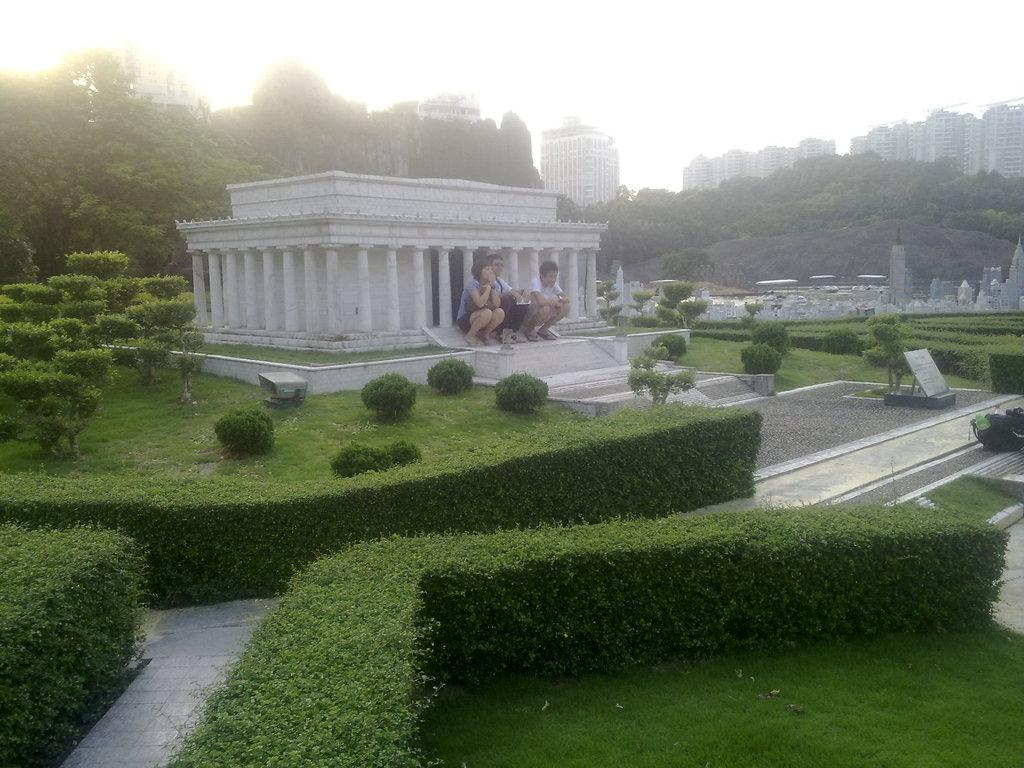What type of structures can be seen in the image? There are buildings in the image. What other natural elements are present in the image? There are trees and green grass in the image. What are the people in the image doing? There are people sitting in the image. What object can be seen with text or information on it? There is a board visible in the image. What is the color of the sky in the image? The sky appears to be white in color. How does the expert answer the quiet question in the image? There is no expert or question present in the image. 